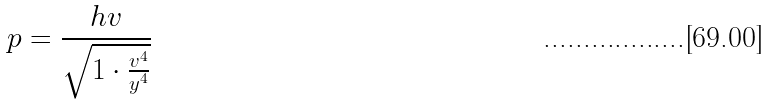Convert formula to latex. <formula><loc_0><loc_0><loc_500><loc_500>p = \frac { h v } { \sqrt { 1 \cdot \frac { v ^ { 4 } } { y ^ { 4 } } } }</formula> 